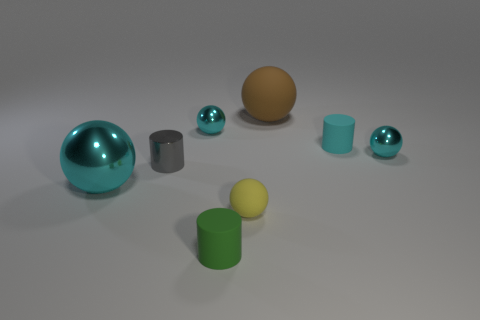What is the material of the tiny cylinder that is the same color as the big metal sphere?
Your answer should be compact. Rubber. Is there a large cyan object that has the same shape as the gray shiny thing?
Keep it short and to the point. No. What number of other small rubber objects are the same shape as the cyan rubber thing?
Provide a succinct answer. 1. Are there fewer small cyan objects than big cyan metallic spheres?
Your answer should be compact. No. What is the material of the tiny green cylinder in front of the large brown thing?
Provide a succinct answer. Rubber. There is a yellow sphere that is the same size as the metal cylinder; what material is it?
Your answer should be compact. Rubber. There is a small cyan sphere right of the tiny cyan thing left of the tiny cylinder that is in front of the tiny gray shiny object; what is it made of?
Your answer should be very brief. Metal. Is the size of the metallic object that is on the left side of the shiny cylinder the same as the big brown matte object?
Make the answer very short. Yes. Is the number of tiny red spheres greater than the number of green cylinders?
Provide a short and direct response. No. What number of big objects are gray metallic objects or blue metal cylinders?
Offer a terse response. 0. 